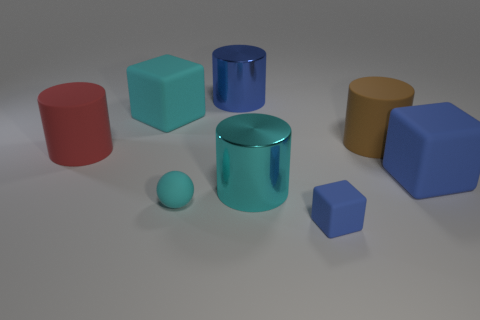Subtract all tiny rubber cubes. How many cubes are left? 2 Add 2 tiny purple cylinders. How many objects exist? 10 Subtract 2 cylinders. How many cylinders are left? 2 Subtract all yellow cylinders. How many blue blocks are left? 2 Subtract all cyan cubes. How many cubes are left? 2 Subtract all balls. How many objects are left? 7 Subtract all green cylinders. Subtract all green cubes. How many cylinders are left? 4 Subtract all large cyan shiny objects. Subtract all tiny cyan shiny blocks. How many objects are left? 7 Add 7 big cyan rubber objects. How many big cyan rubber objects are left? 8 Add 4 big brown rubber cylinders. How many big brown rubber cylinders exist? 5 